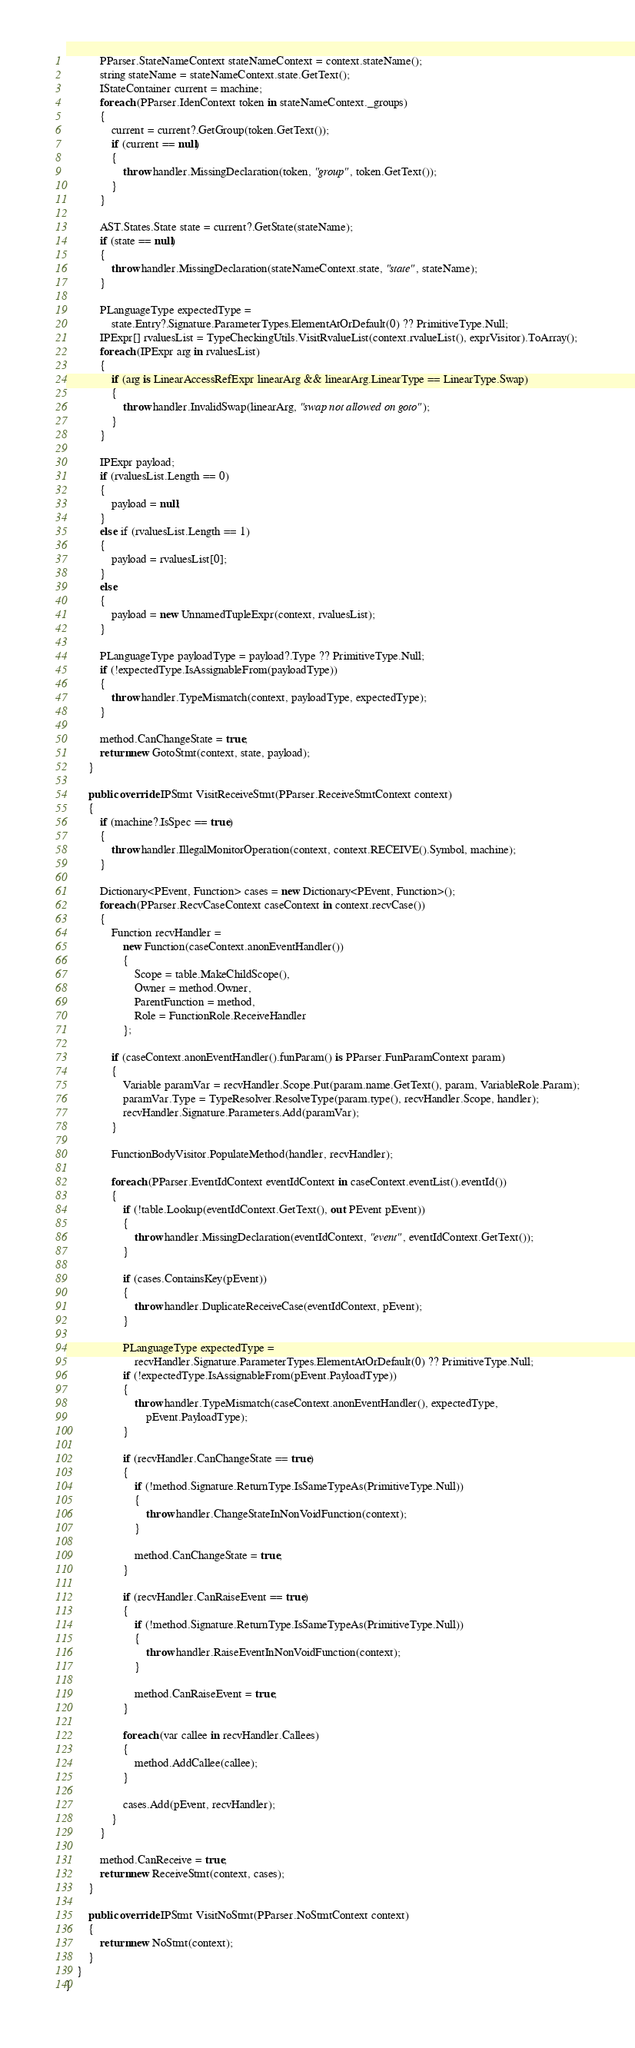Convert code to text. <code><loc_0><loc_0><loc_500><loc_500><_C#_>
            PParser.StateNameContext stateNameContext = context.stateName();
            string stateName = stateNameContext.state.GetText();
            IStateContainer current = machine;
            foreach (PParser.IdenContext token in stateNameContext._groups)
            {
                current = current?.GetGroup(token.GetText());
                if (current == null)
                {
                    throw handler.MissingDeclaration(token, "group", token.GetText());
                }
            }

            AST.States.State state = current?.GetState(stateName);
            if (state == null)
            {
                throw handler.MissingDeclaration(stateNameContext.state, "state", stateName);
            }

            PLanguageType expectedType =
                state.Entry?.Signature.ParameterTypes.ElementAtOrDefault(0) ?? PrimitiveType.Null;
            IPExpr[] rvaluesList = TypeCheckingUtils.VisitRvalueList(context.rvalueList(), exprVisitor).ToArray();
            foreach (IPExpr arg in rvaluesList)
            {
                if (arg is LinearAccessRefExpr linearArg && linearArg.LinearType == LinearType.Swap)
                {
                    throw handler.InvalidSwap(linearArg, "swap not allowed on goto");
                }
            }

            IPExpr payload;
            if (rvaluesList.Length == 0)
            {
                payload = null;
            }
            else if (rvaluesList.Length == 1)
            {
                payload = rvaluesList[0];
            }
            else
            {
                payload = new UnnamedTupleExpr(context, rvaluesList);
            }

            PLanguageType payloadType = payload?.Type ?? PrimitiveType.Null;
            if (!expectedType.IsAssignableFrom(payloadType))
            {
                throw handler.TypeMismatch(context, payloadType, expectedType);
            }

            method.CanChangeState = true;
            return new GotoStmt(context, state, payload);
        }

        public override IPStmt VisitReceiveStmt(PParser.ReceiveStmtContext context)
        {
            if (machine?.IsSpec == true)
            {
                throw handler.IllegalMonitorOperation(context, context.RECEIVE().Symbol, machine);
            }

            Dictionary<PEvent, Function> cases = new Dictionary<PEvent, Function>();
            foreach (PParser.RecvCaseContext caseContext in context.recvCase())
            {
                Function recvHandler =
                    new Function(caseContext.anonEventHandler())
                    {
                        Scope = table.MakeChildScope(),
                        Owner = method.Owner,
                        ParentFunction = method,
                        Role = FunctionRole.ReceiveHandler
                    };

                if (caseContext.anonEventHandler().funParam() is PParser.FunParamContext param)
                {
                    Variable paramVar = recvHandler.Scope.Put(param.name.GetText(), param, VariableRole.Param);
                    paramVar.Type = TypeResolver.ResolveType(param.type(), recvHandler.Scope, handler);
                    recvHandler.Signature.Parameters.Add(paramVar);
                }

                FunctionBodyVisitor.PopulateMethod(handler, recvHandler);

                foreach (PParser.EventIdContext eventIdContext in caseContext.eventList().eventId())
                {
                    if (!table.Lookup(eventIdContext.GetText(), out PEvent pEvent))
                    {
                        throw handler.MissingDeclaration(eventIdContext, "event", eventIdContext.GetText());
                    }

                    if (cases.ContainsKey(pEvent))
                    {
                        throw handler.DuplicateReceiveCase(eventIdContext, pEvent);
                    }

                    PLanguageType expectedType =
                        recvHandler.Signature.ParameterTypes.ElementAtOrDefault(0) ?? PrimitiveType.Null;
                    if (!expectedType.IsAssignableFrom(pEvent.PayloadType))
                    {
                        throw handler.TypeMismatch(caseContext.anonEventHandler(), expectedType,
                            pEvent.PayloadType);
                    }

                    if (recvHandler.CanChangeState == true)
                    {
                        if (!method.Signature.ReturnType.IsSameTypeAs(PrimitiveType.Null))
                        {
                            throw handler.ChangeStateInNonVoidFunction(context);
                        }

                        method.CanChangeState = true;
                    }

                    if (recvHandler.CanRaiseEvent == true)
                    {
                        if (!method.Signature.ReturnType.IsSameTypeAs(PrimitiveType.Null))
                        {
                            throw handler.RaiseEventInNonVoidFunction(context);
                        }

                        method.CanRaiseEvent = true;
                    }

                    foreach (var callee in recvHandler.Callees)
                    {
                        method.AddCallee(callee);
                    }

                    cases.Add(pEvent, recvHandler);
                }
            }

            method.CanReceive = true;
            return new ReceiveStmt(context, cases);
        }

        public override IPStmt VisitNoStmt(PParser.NoStmtContext context)
        {
            return new NoStmt(context);
        }
    }
}</code> 